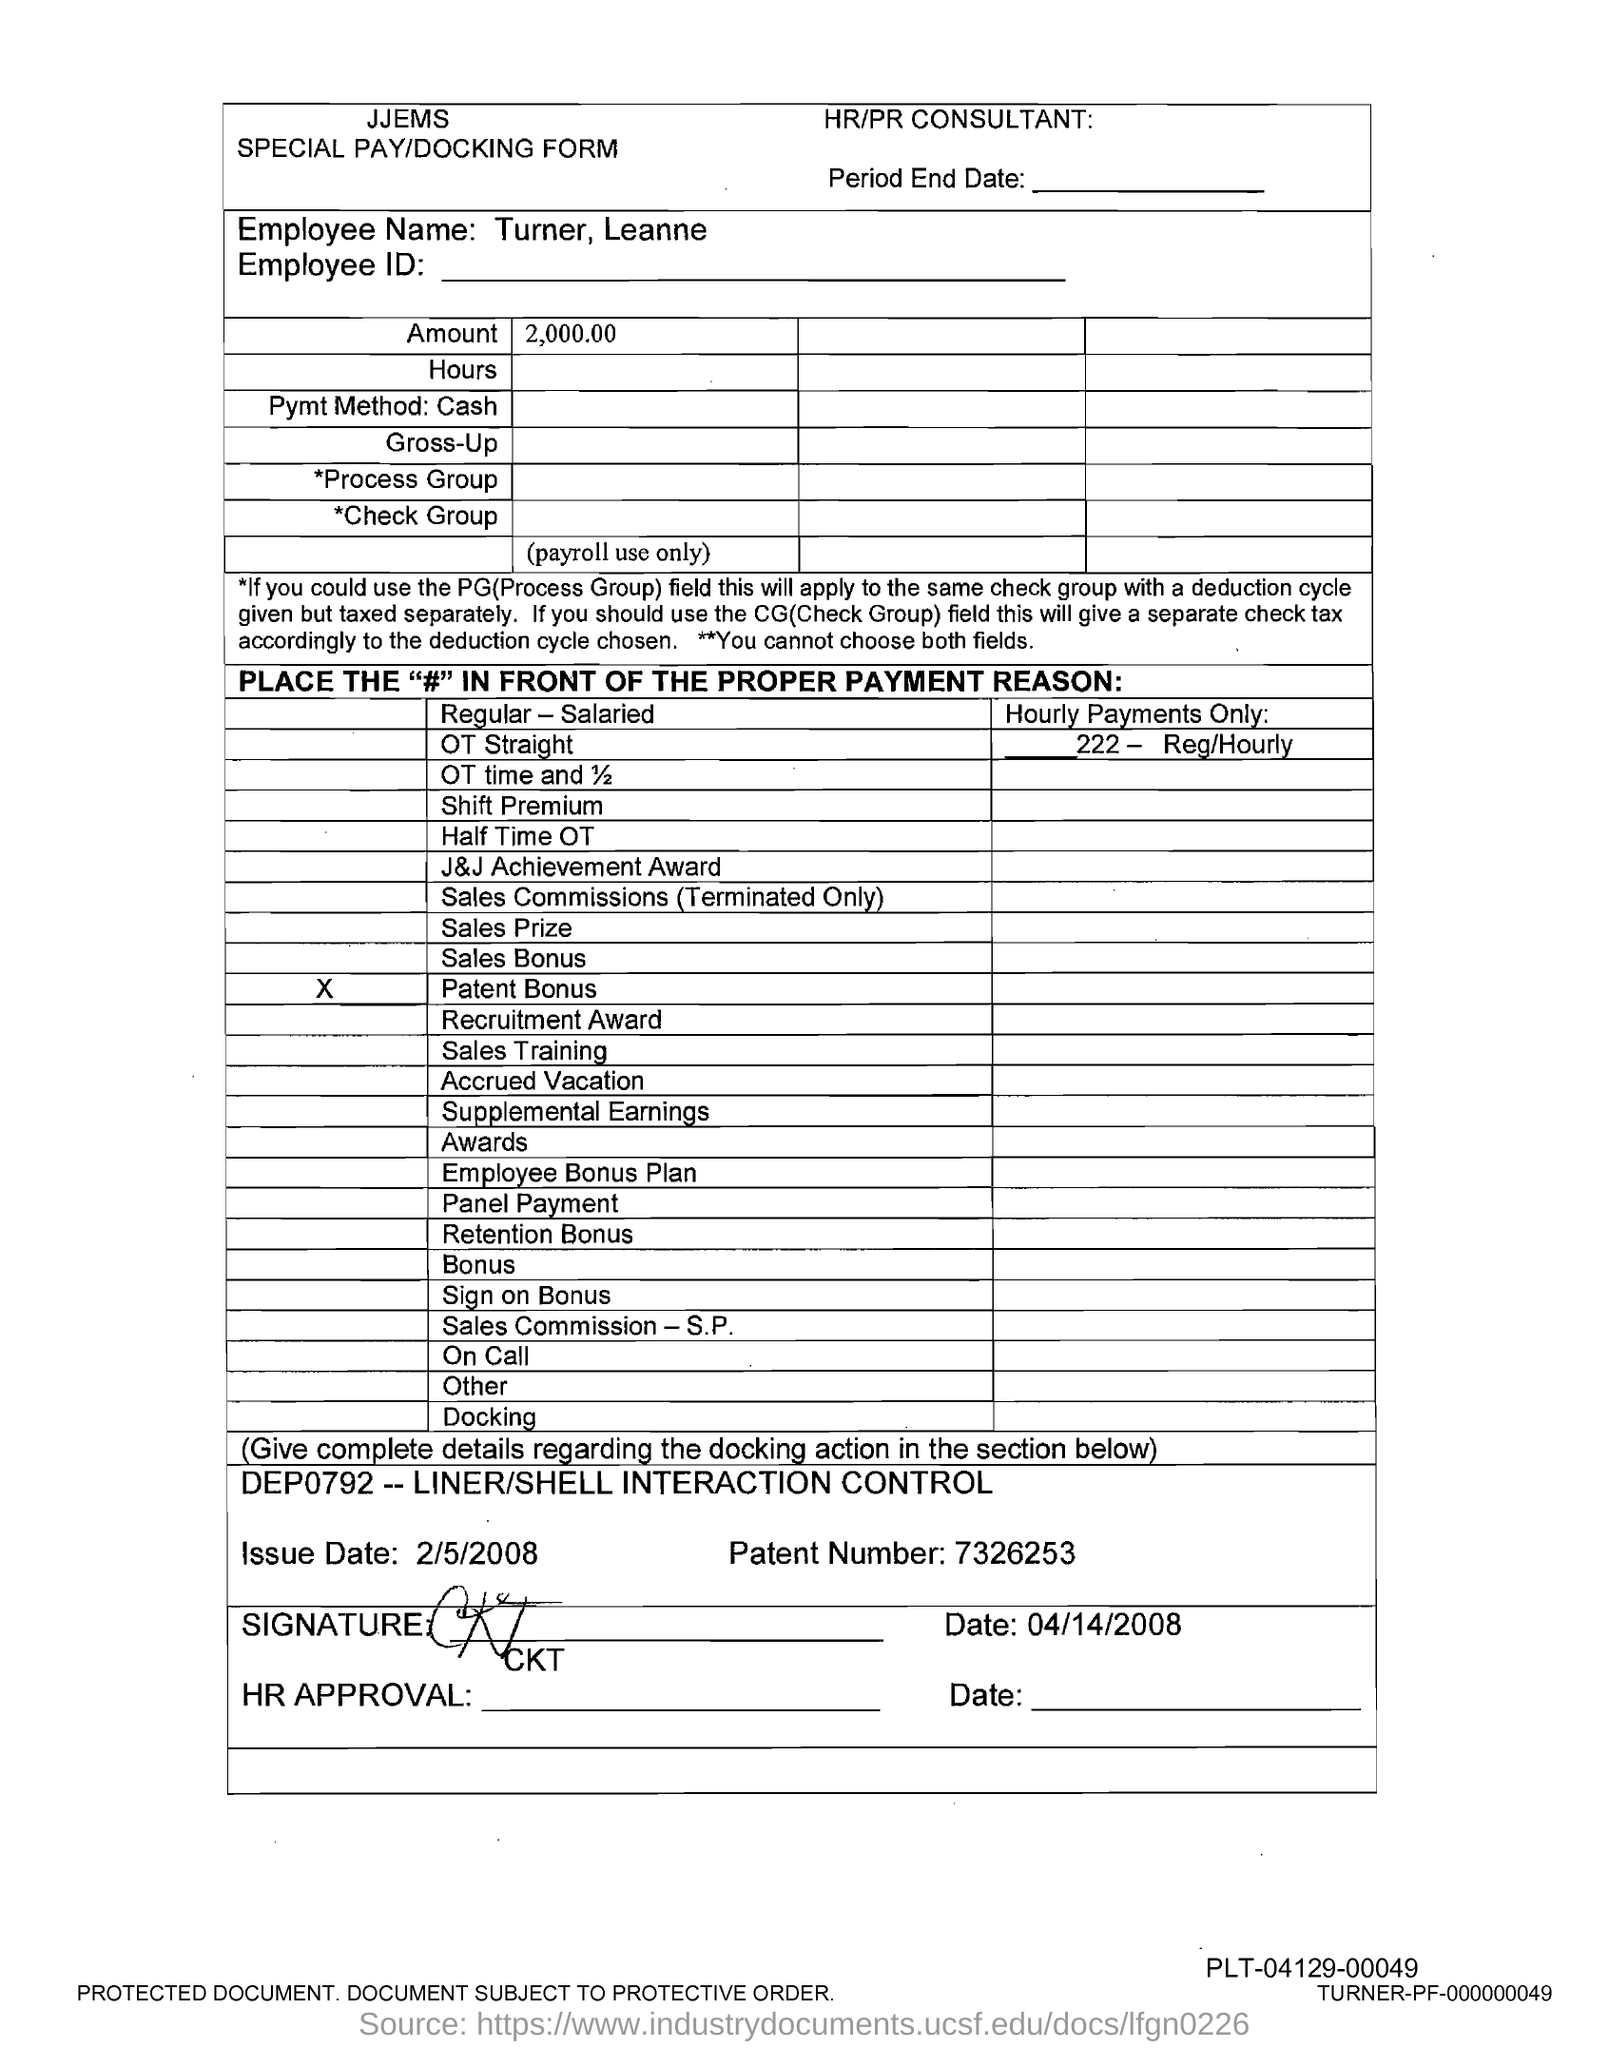What is the Patent number?
Keep it short and to the point. 7326253. What is the amount?
Provide a short and direct response. 2,000.00. 